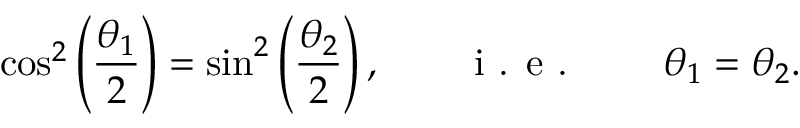Convert formula to latex. <formula><loc_0><loc_0><loc_500><loc_500>\cos ^ { 2 } \left ( \frac { \theta _ { 1 } } { 2 } \right ) = \sin ^ { 2 } \left ( \frac { \theta _ { 2 } } { 2 } \right ) , \quad i . e . \quad \theta _ { 1 } = \theta _ { 2 } .</formula> 